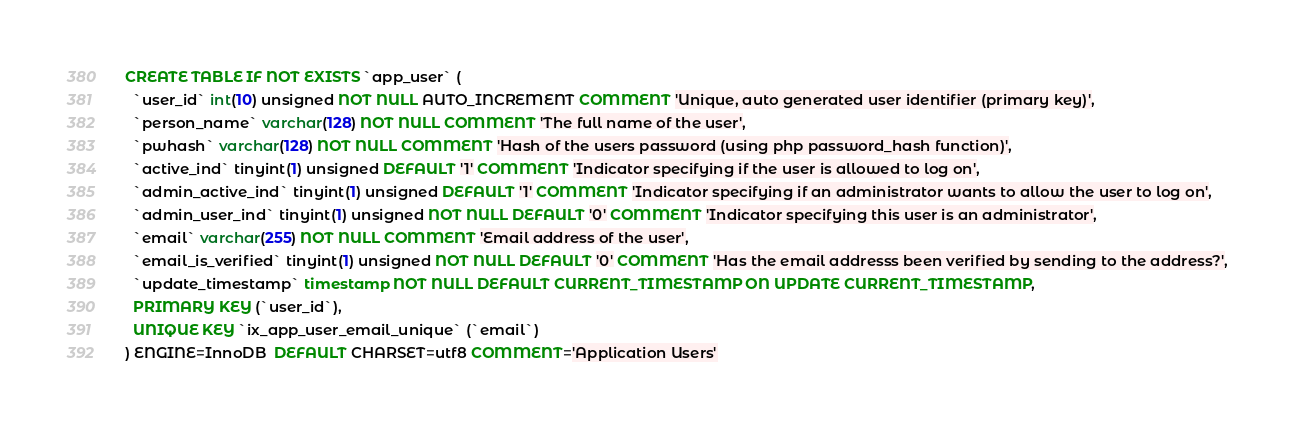Convert code to text. <code><loc_0><loc_0><loc_500><loc_500><_SQL_>CREATE TABLE IF NOT EXISTS `app_user` (
  `user_id` int(10) unsigned NOT NULL AUTO_INCREMENT COMMENT 'Unique, auto generated user identifier (primary key)',
  `person_name` varchar(128) NOT NULL COMMENT 'The full name of the user',
  `pwhash` varchar(128) NOT NULL COMMENT 'Hash of the users password (using php password_hash function)',
  `active_ind` tinyint(1) unsigned DEFAULT '1' COMMENT 'Indicator specifying if the user is allowed to log on',
  `admin_active_ind` tinyint(1) unsigned DEFAULT '1' COMMENT 'Indicator specifying if an administrator wants to allow the user to log on',
  `admin_user_ind` tinyint(1) unsigned NOT NULL DEFAULT '0' COMMENT 'Indicator specifying this user is an administrator',
  `email` varchar(255) NOT NULL COMMENT 'Email address of the user',
  `email_is_verified` tinyint(1) unsigned NOT NULL DEFAULT '0' COMMENT 'Has the email addresss been verified by sending to the address?',
  `update_timestamp` timestamp NOT NULL DEFAULT CURRENT_TIMESTAMP ON UPDATE CURRENT_TIMESTAMP,
  PRIMARY KEY (`user_id`),
  UNIQUE KEY `ix_app_user_email_unique` (`email`)
) ENGINE=InnoDB  DEFAULT CHARSET=utf8 COMMENT='Application Users'
</code> 